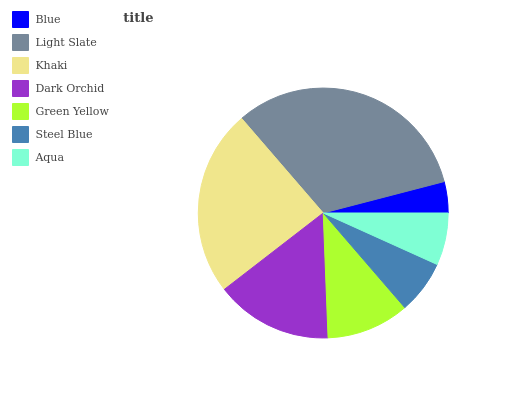Is Blue the minimum?
Answer yes or no. Yes. Is Light Slate the maximum?
Answer yes or no. Yes. Is Khaki the minimum?
Answer yes or no. No. Is Khaki the maximum?
Answer yes or no. No. Is Light Slate greater than Khaki?
Answer yes or no. Yes. Is Khaki less than Light Slate?
Answer yes or no. Yes. Is Khaki greater than Light Slate?
Answer yes or no. No. Is Light Slate less than Khaki?
Answer yes or no. No. Is Green Yellow the high median?
Answer yes or no. Yes. Is Green Yellow the low median?
Answer yes or no. Yes. Is Steel Blue the high median?
Answer yes or no. No. Is Steel Blue the low median?
Answer yes or no. No. 